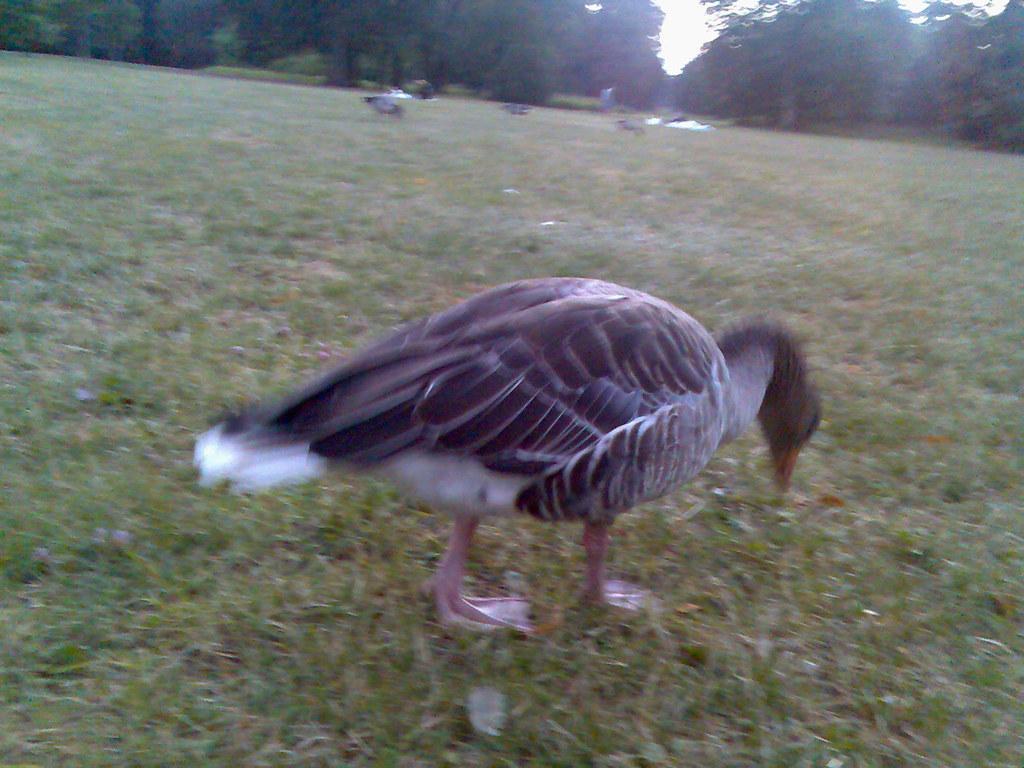How would you summarize this image in a sentence or two? In this image we can see a bird on the grassy land. Background of the image trees are present. 